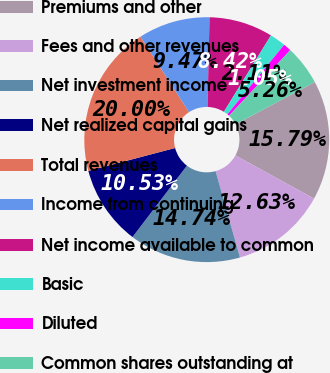Convert chart. <chart><loc_0><loc_0><loc_500><loc_500><pie_chart><fcel>Premiums and other<fcel>Fees and other revenues<fcel>Net investment income<fcel>Net realized capital gains<fcel>Total revenues<fcel>Income from continuing<fcel>Net income available to common<fcel>Basic<fcel>Diluted<fcel>Common shares outstanding at<nl><fcel>15.79%<fcel>12.63%<fcel>14.74%<fcel>10.53%<fcel>20.0%<fcel>9.47%<fcel>8.42%<fcel>2.11%<fcel>1.05%<fcel>5.26%<nl></chart> 